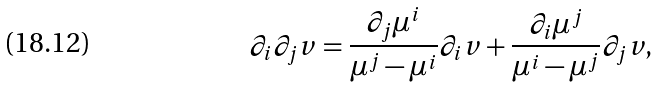Convert formula to latex. <formula><loc_0><loc_0><loc_500><loc_500>\partial _ { i } \partial _ { j } v = \frac { \partial _ { j } \mu ^ { i } } { \mu ^ { j } - \mu ^ { i } } \partial _ { i } v + \frac { \partial _ { i } \mu ^ { j } } { \mu ^ { i } - \mu ^ { j } } \partial _ { j } v ,</formula> 